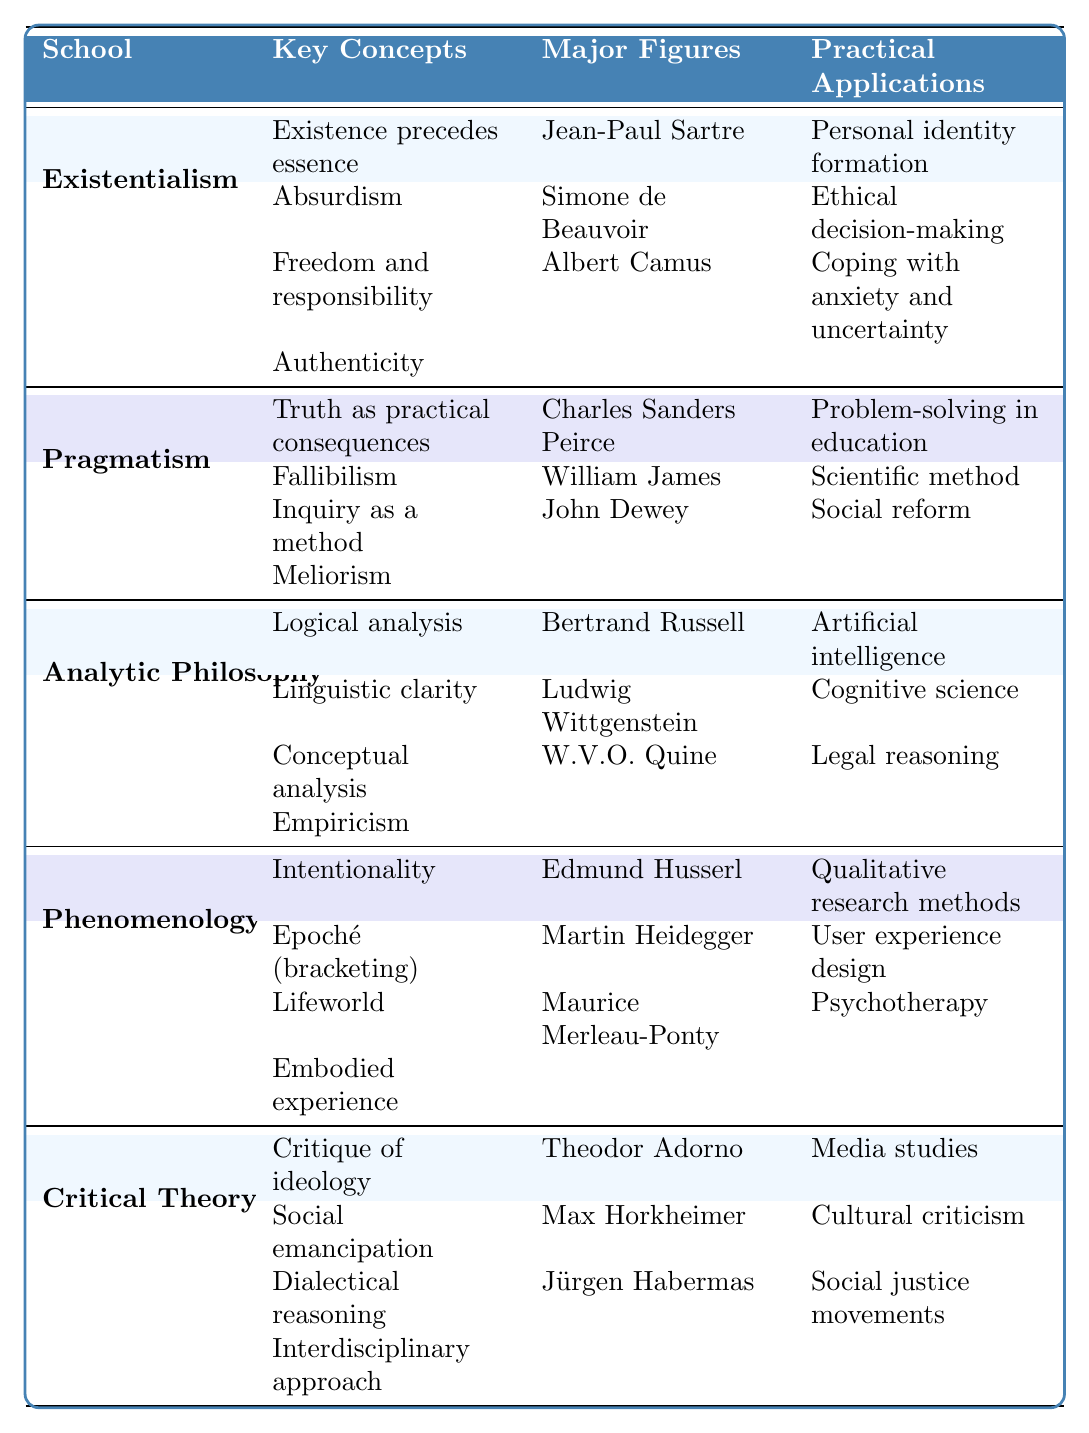What are the key concepts associated with Existentialism? The table lists the key concepts under the "Existentialism" school in the second column. They are: "Existence precedes essence," "Absurdism," "Freedom and responsibility," and "Authenticity."
Answer: Existence precedes essence, Absurdism, Freedom and responsibility, Authenticity Which major figure is associated with Pragmatism? In the third column under "Pragmatism," the major figures are listed. They include "Charles Sanders Peirce," "William James," and "John Dewey." Any of these names is a correct answer.
Answer: Charles Sanders Peirce (or William James, or John Dewey) What are the practical applications of Critical Theory? The table shows the practical applications under the "Critical Theory" school, which are: "Media studies," "Cultural criticism," and "Social justice movements."
Answer: Media studies, Cultural criticism, Social justice movements How many key concepts are listed for Analytic Philosophy? In the second column under the "Analytic Philosophy" section, there are four key concepts listed: "Logical analysis," "Linguistic clarity," "Conceptual analysis," and "Empiricism." Therefore, there are four key concepts in total.
Answer: 4 Is "Coping with anxiety and uncertainty" a practical application of Existentialism? "Coping with anxiety and uncertainty" is listed under the practical applications in the Existentialism section of the table, making the statement true.
Answer: Yes Which school of thought has "Interdisciplinary approach" as a key concept? The fourth column of the table shows that "Interdisciplinary approach" is listed under the practical applications of "Critical Theory." Since the question asks for a school of thought, the response should focus on "Critical Theory."
Answer: Critical Theory How many major figures are there associated with Phenomenology? The third column under "Phenomenology" lists three major figures: "Edmund Husserl," "Martin Heidegger," and "Maurice Merleau-Ponty." When counting these names, the total is three.
Answer: 3 Which key concept is unique to Pragmatism compared to the other schools of thought in the table? The key concept "Truth as practical consequences" appears under Pragmatism and does not appear as a key concept for any other school listed in the table. This indicates that it is a unique concept.
Answer: Truth as practical consequences What is the relationship between the major figures and the practical applications of Existentialism? The table shows that each key figure in the Existentialism section contributes to its practical applications. For example, Sartre's work relates to personal identity, Beauvoir with ethical decision-making, and Camus with coping strategies. This establishes a direct relation between major figures and their contributions.
Answer: They contribute to personal identity, ethical decision-making, and coping with anxiety Which school of thought has key concepts involving intentionality and embodied experience? The table indicates that "Intentionality" and "Embodied experience" are key concepts listed under the "Phenomenology" school of thought. Therefore, Phenomenology has these key concepts.
Answer: Phenomenology 